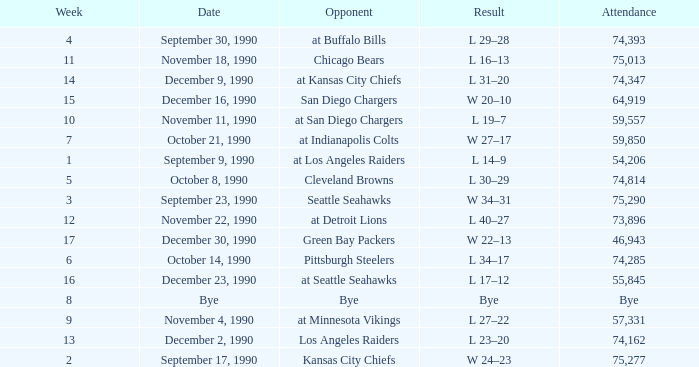What day was the attendance 74,285? October 14, 1990. 